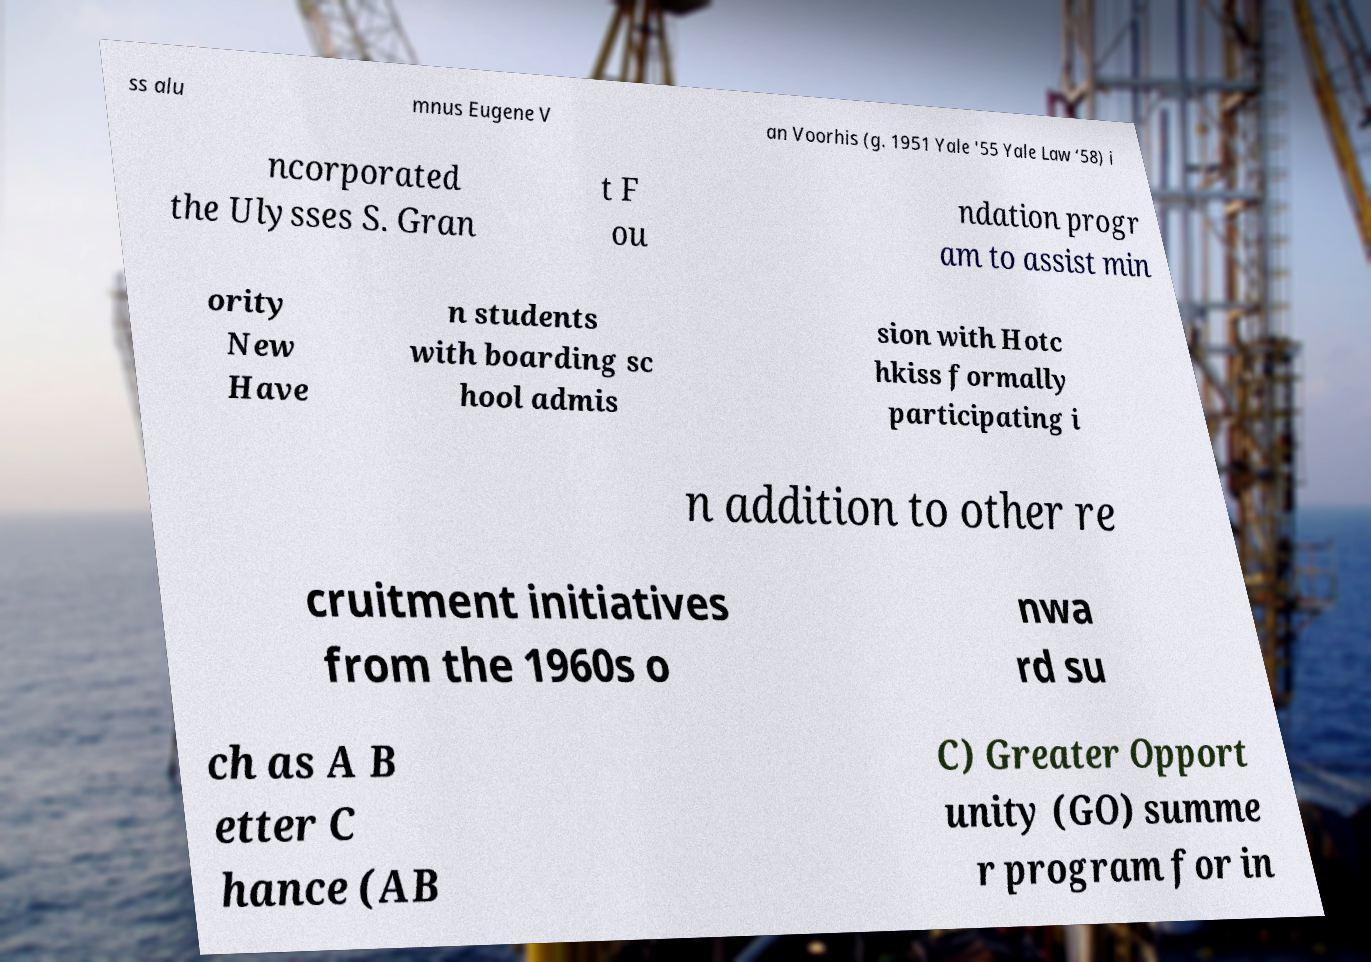For documentation purposes, I need the text within this image transcribed. Could you provide that? ss alu mnus Eugene V an Voorhis (g. 1951 Yale '55 Yale Law ‘58) i ncorporated the Ulysses S. Gran t F ou ndation progr am to assist min ority New Have n students with boarding sc hool admis sion with Hotc hkiss formally participating i n addition to other re cruitment initiatives from the 1960s o nwa rd su ch as A B etter C hance (AB C) Greater Opport unity (GO) summe r program for in 